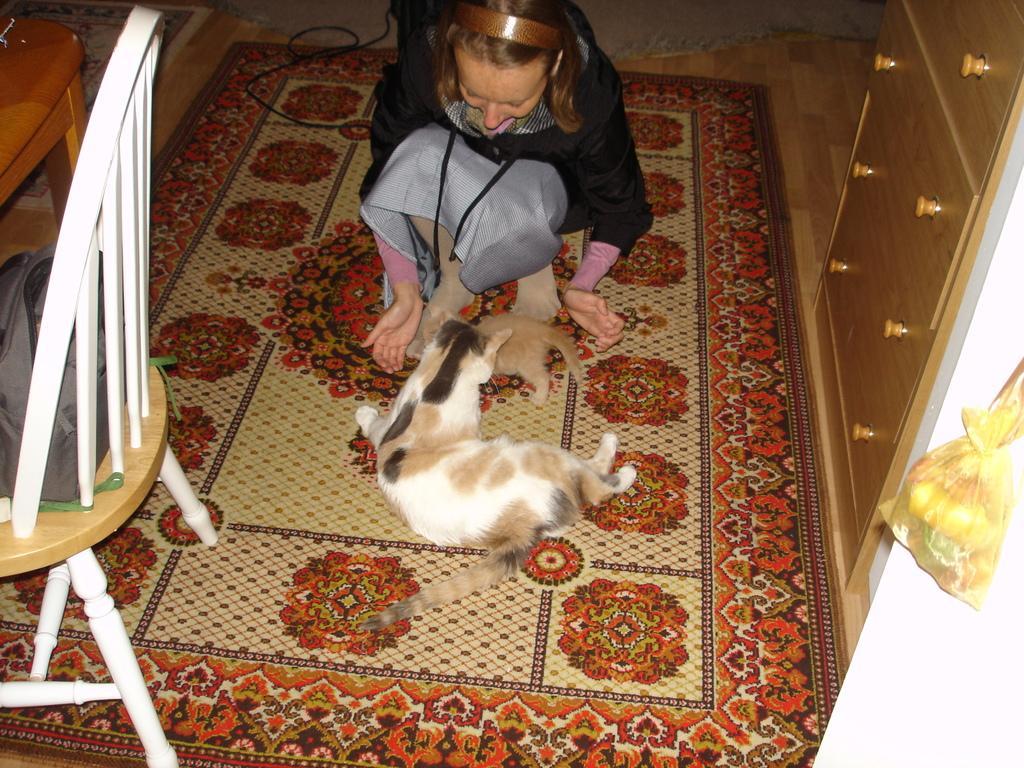In one or two sentences, can you explain what this image depicts? Here in this picture we can see a woman playing with a animal. This is a floor carpet. Here we can see desk at the right side of the picture and cover. And on the left side of the picture we can see a chair and a bag on it. 